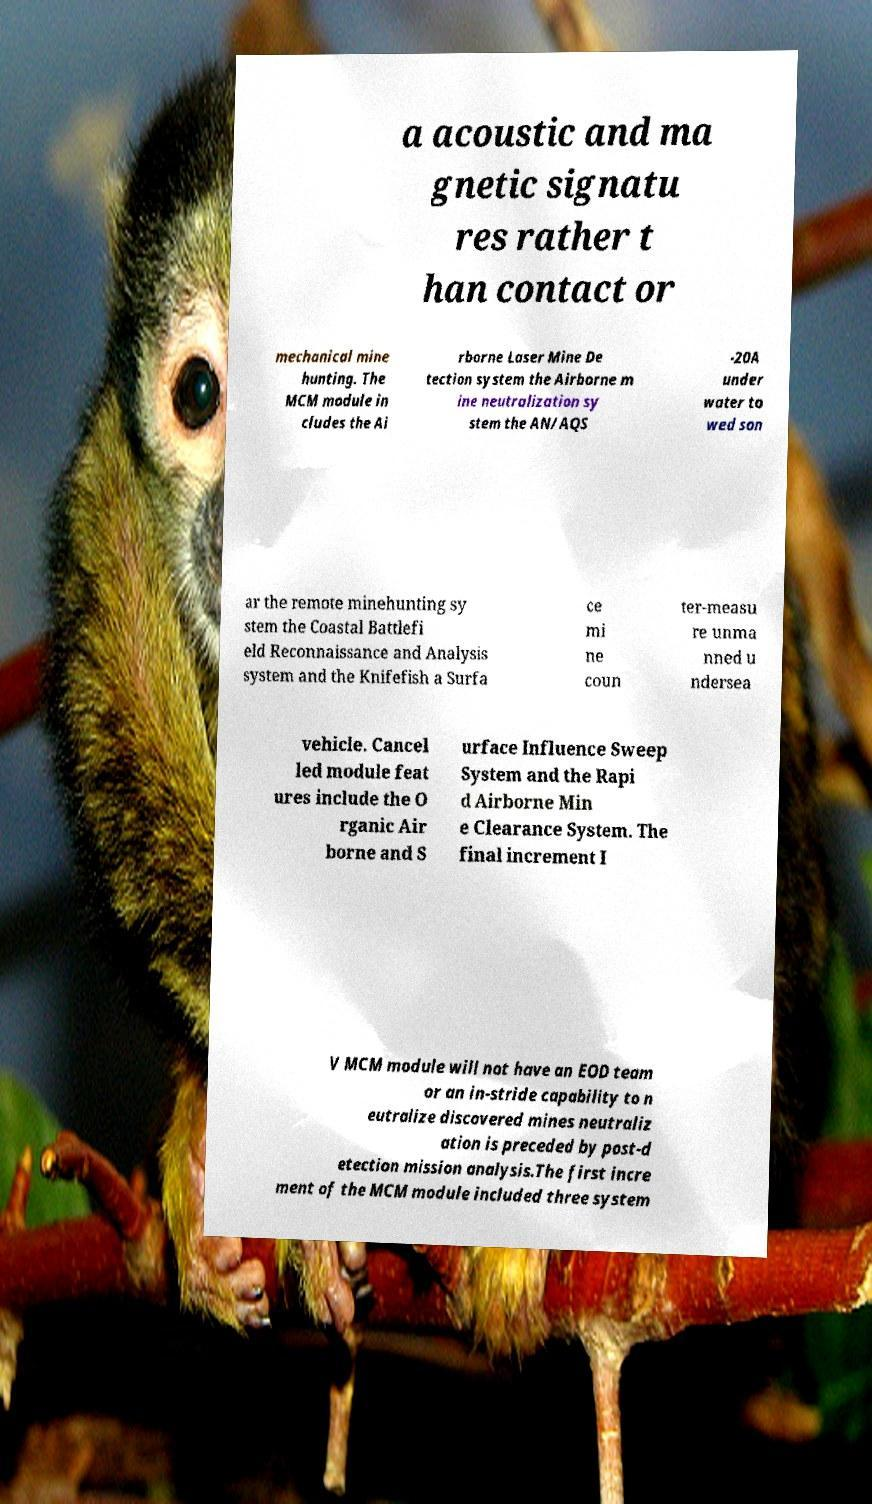Could you assist in decoding the text presented in this image and type it out clearly? a acoustic and ma gnetic signatu res rather t han contact or mechanical mine hunting. The MCM module in cludes the Ai rborne Laser Mine De tection system the Airborne m ine neutralization sy stem the AN/AQS -20A under water to wed son ar the remote minehunting sy stem the Coastal Battlefi eld Reconnaissance and Analysis system and the Knifefish a Surfa ce mi ne coun ter-measu re unma nned u ndersea vehicle. Cancel led module feat ures include the O rganic Air borne and S urface Influence Sweep System and the Rapi d Airborne Min e Clearance System. The final increment I V MCM module will not have an EOD team or an in-stride capability to n eutralize discovered mines neutraliz ation is preceded by post-d etection mission analysis.The first incre ment of the MCM module included three system 